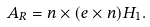<formula> <loc_0><loc_0><loc_500><loc_500>A _ { R } = n \times ( e \times n ) H _ { 1 } .</formula> 